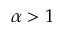Convert formula to latex. <formula><loc_0><loc_0><loc_500><loc_500>\alpha > 1</formula> 